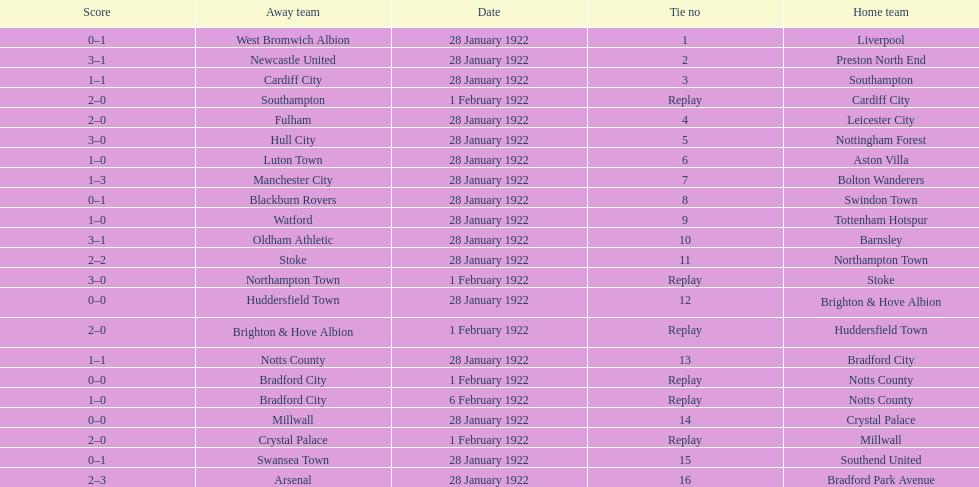What was the score in the aston villa game? 1–0. Which other team had an identical score? Tottenham Hotspur. 